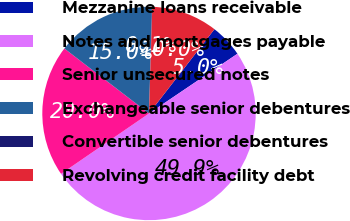Convert chart to OTSL. <chart><loc_0><loc_0><loc_500><loc_500><pie_chart><fcel>Mezzanine loans receivable<fcel>Notes and mortgages payable<fcel>Senior unsecured notes<fcel>Exchangeable senior debentures<fcel>Convertible senior debentures<fcel>Revolving credit facility debt<nl><fcel>5.04%<fcel>49.88%<fcel>19.99%<fcel>15.01%<fcel>0.06%<fcel>10.02%<nl></chart> 